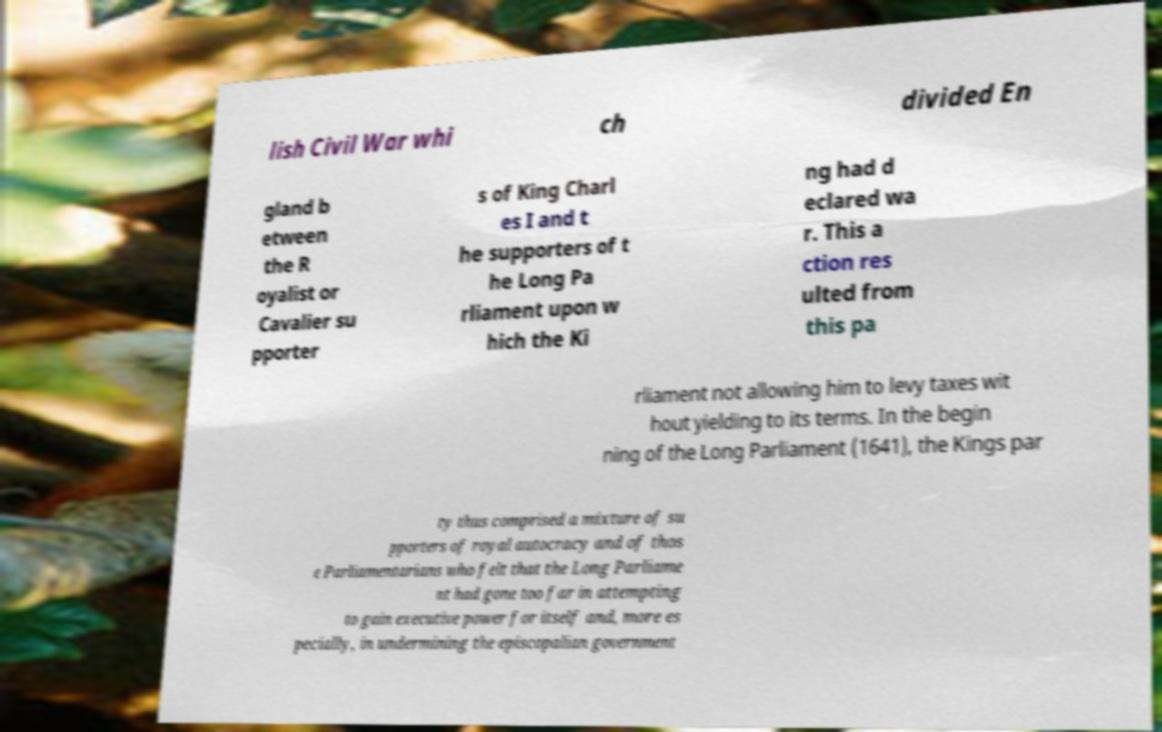Could you extract and type out the text from this image? lish Civil War whi ch divided En gland b etween the R oyalist or Cavalier su pporter s of King Charl es I and t he supporters of t he Long Pa rliament upon w hich the Ki ng had d eclared wa r. This a ction res ulted from this pa rliament not allowing him to levy taxes wit hout yielding to its terms. In the begin ning of the Long Parliament (1641), the Kings par ty thus comprised a mixture of su pporters of royal autocracy and of thos e Parliamentarians who felt that the Long Parliame nt had gone too far in attempting to gain executive power for itself and, more es pecially, in undermining the episcopalian government 